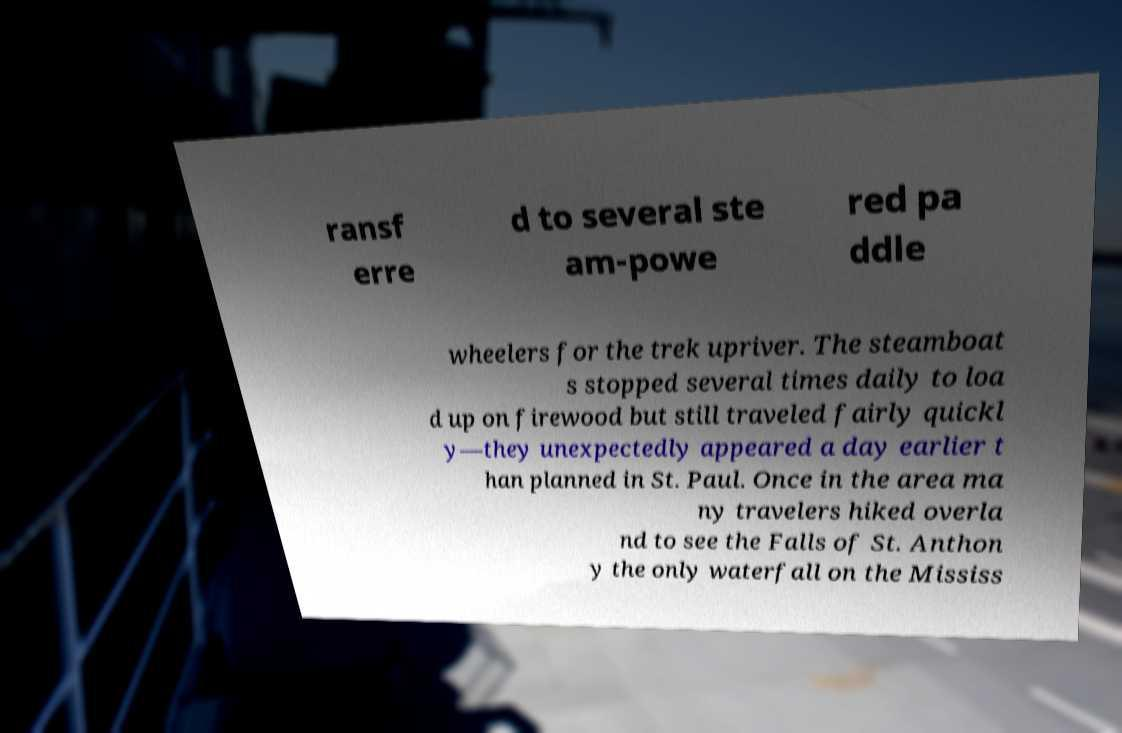There's text embedded in this image that I need extracted. Can you transcribe it verbatim? ransf erre d to several ste am-powe red pa ddle wheelers for the trek upriver. The steamboat s stopped several times daily to loa d up on firewood but still traveled fairly quickl y—they unexpectedly appeared a day earlier t han planned in St. Paul. Once in the area ma ny travelers hiked overla nd to see the Falls of St. Anthon y the only waterfall on the Mississ 